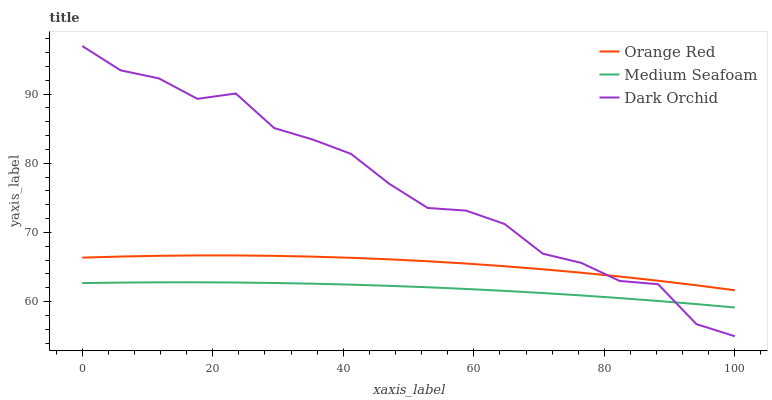Does Medium Seafoam have the minimum area under the curve?
Answer yes or no. Yes. Does Dark Orchid have the maximum area under the curve?
Answer yes or no. Yes. Does Dark Orchid have the minimum area under the curve?
Answer yes or no. No. Does Medium Seafoam have the maximum area under the curve?
Answer yes or no. No. Is Medium Seafoam the smoothest?
Answer yes or no. Yes. Is Dark Orchid the roughest?
Answer yes or no. Yes. Is Dark Orchid the smoothest?
Answer yes or no. No. Is Medium Seafoam the roughest?
Answer yes or no. No. Does Dark Orchid have the lowest value?
Answer yes or no. Yes. Does Medium Seafoam have the lowest value?
Answer yes or no. No. Does Dark Orchid have the highest value?
Answer yes or no. Yes. Does Medium Seafoam have the highest value?
Answer yes or no. No. Is Medium Seafoam less than Orange Red?
Answer yes or no. Yes. Is Orange Red greater than Medium Seafoam?
Answer yes or no. Yes. Does Orange Red intersect Dark Orchid?
Answer yes or no. Yes. Is Orange Red less than Dark Orchid?
Answer yes or no. No. Is Orange Red greater than Dark Orchid?
Answer yes or no. No. Does Medium Seafoam intersect Orange Red?
Answer yes or no. No. 